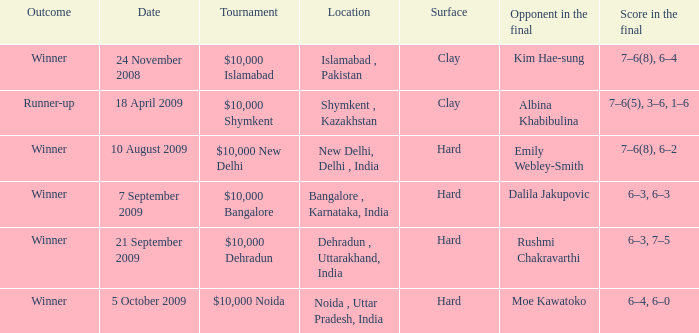What material is the surface made of in noida, uttar pradesh, india? Hard. 